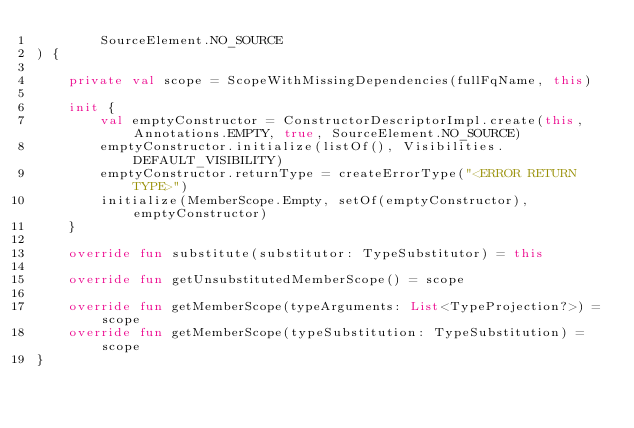<code> <loc_0><loc_0><loc_500><loc_500><_Kotlin_>        SourceElement.NO_SOURCE
) {

    private val scope = ScopeWithMissingDependencies(fullFqName, this)

    init {
        val emptyConstructor = ConstructorDescriptorImpl.create(this, Annotations.EMPTY, true, SourceElement.NO_SOURCE)
        emptyConstructor.initialize(listOf(), Visibilities.DEFAULT_VISIBILITY)
        emptyConstructor.returnType = createErrorType("<ERROR RETURN TYPE>")
        initialize(MemberScope.Empty, setOf(emptyConstructor), emptyConstructor)
    }

    override fun substitute(substitutor: TypeSubstitutor) = this

    override fun getUnsubstitutedMemberScope() = scope

    override fun getMemberScope(typeArguments: List<TypeProjection?>) = scope
    override fun getMemberScope(typeSubstitution: TypeSubstitution) = scope
}
</code> 